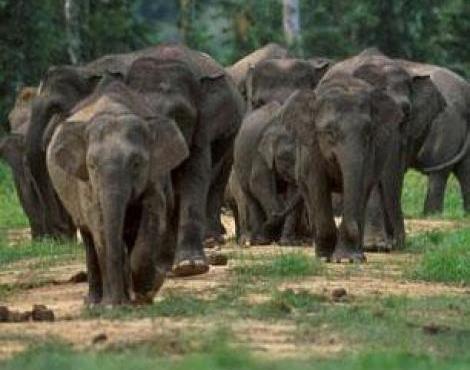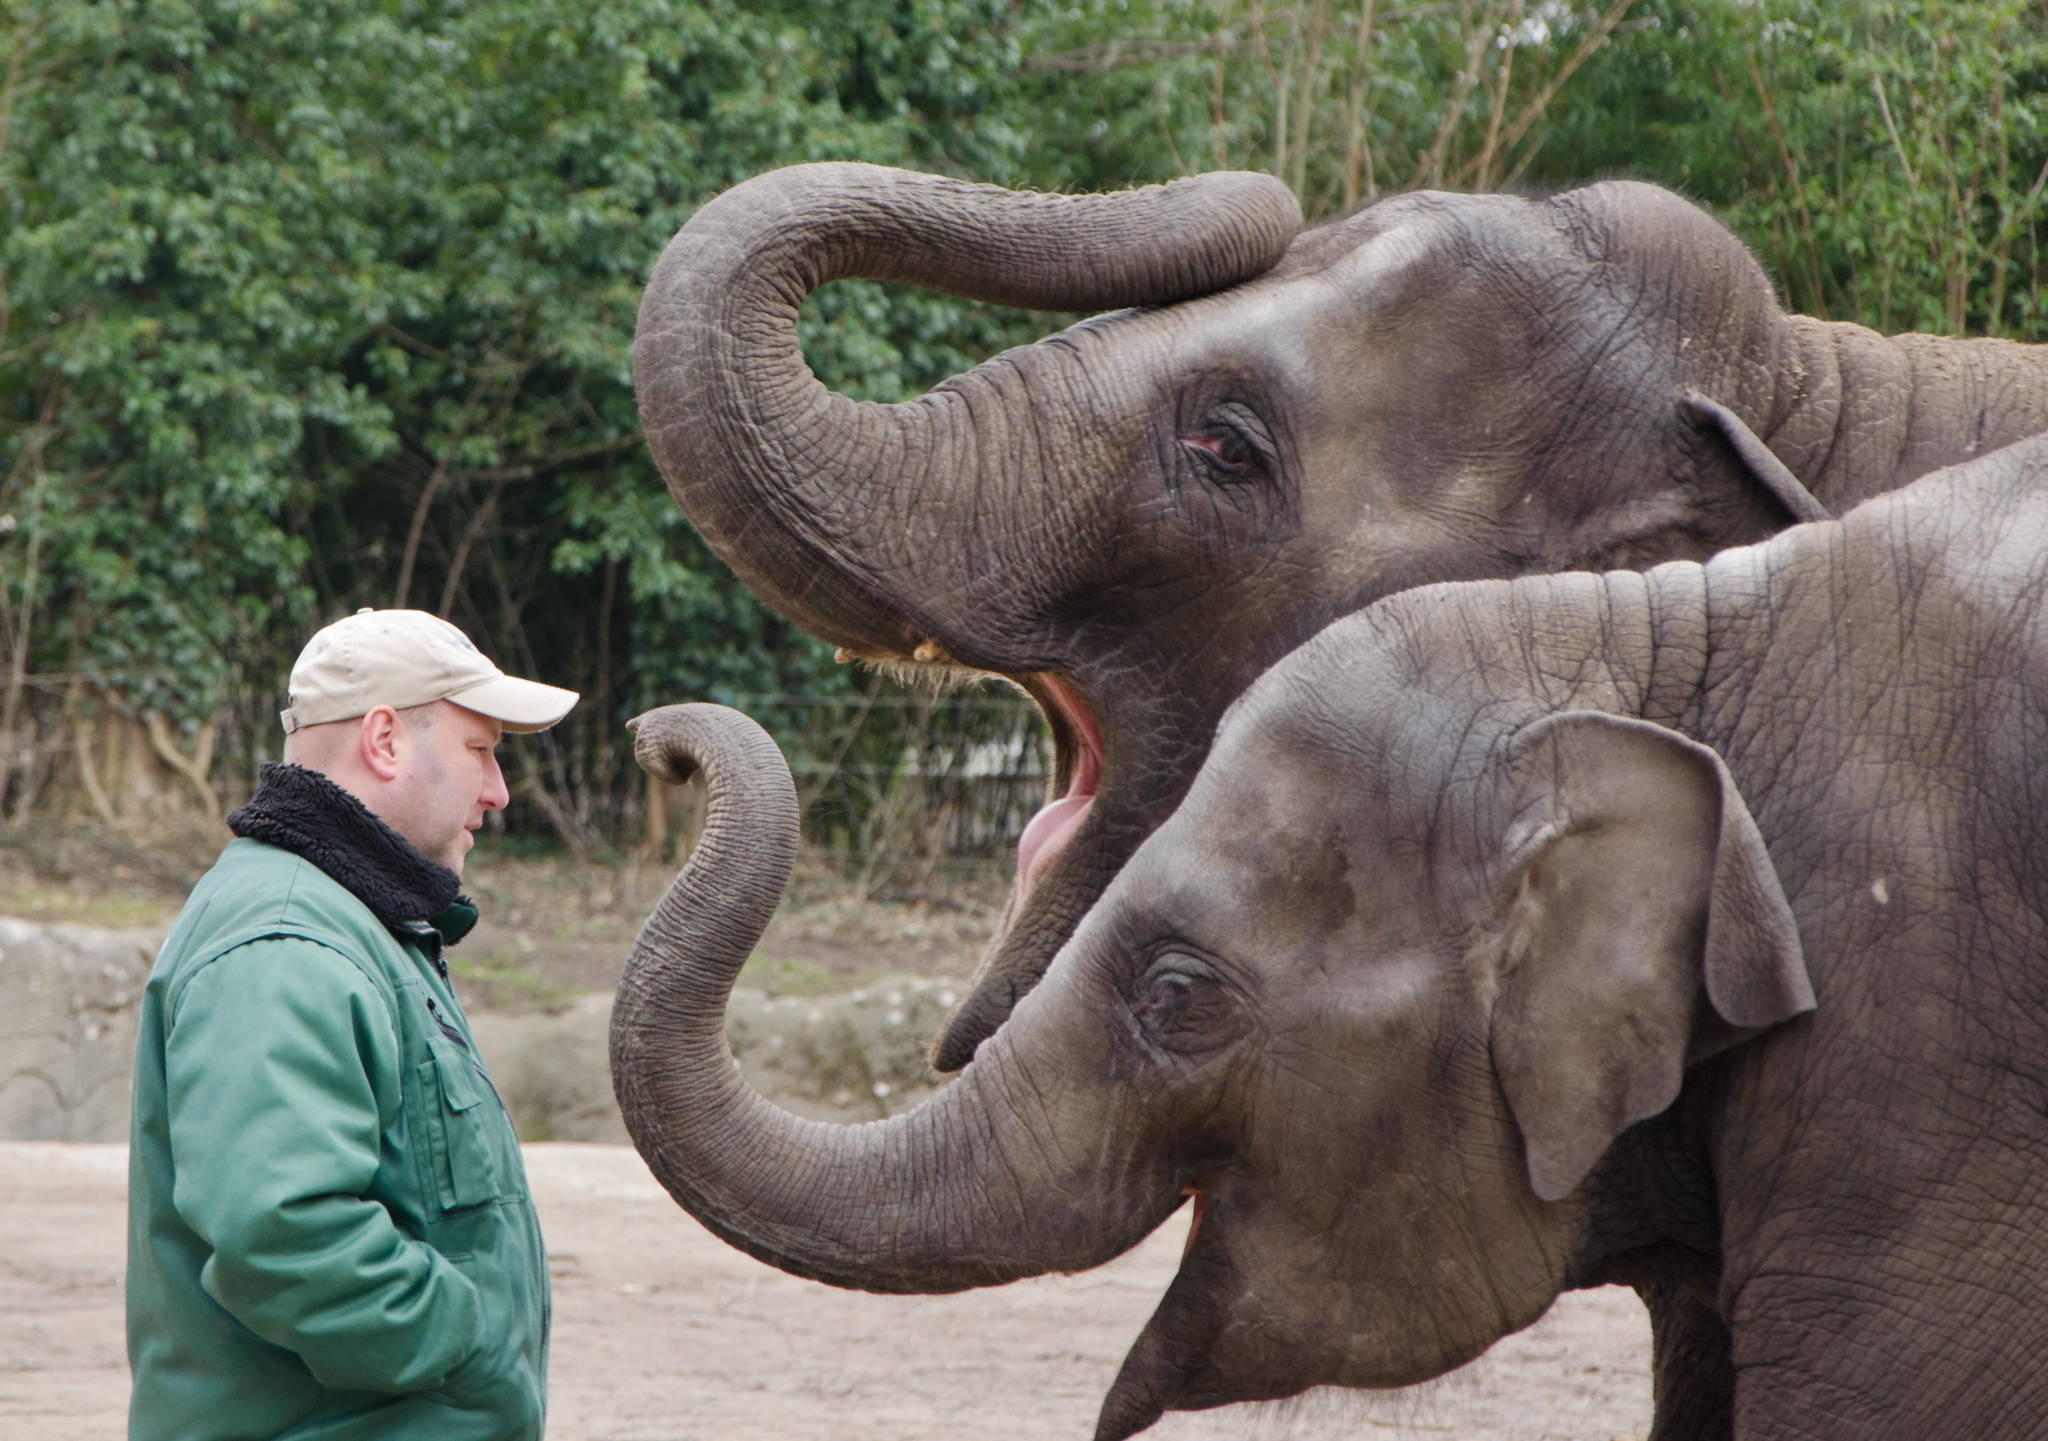The first image is the image on the left, the second image is the image on the right. Given the left and right images, does the statement "One of the images contains more than three elephants." hold true? Answer yes or no. Yes. 